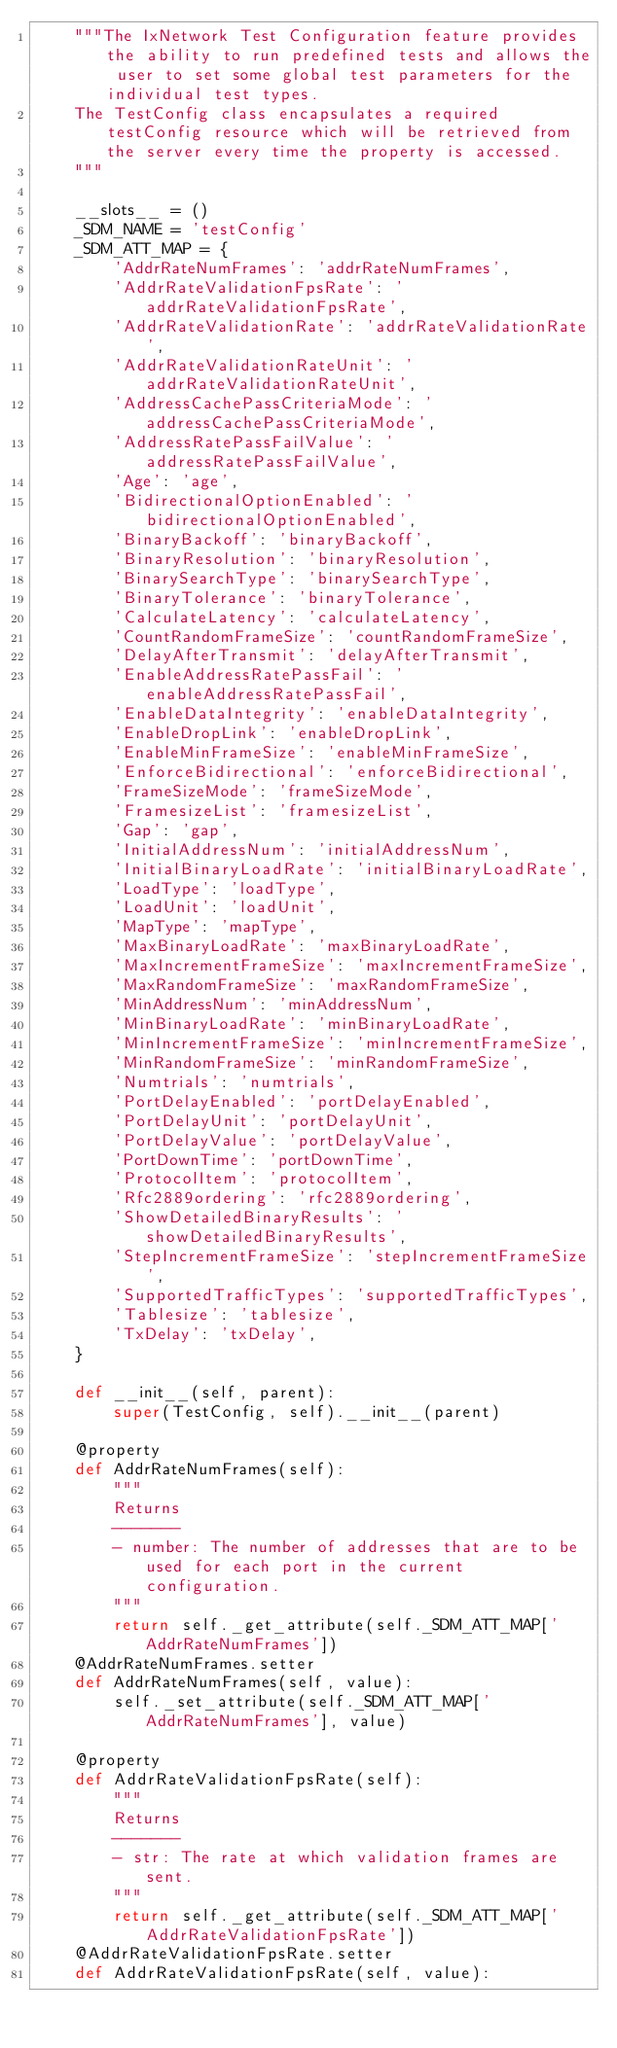Convert code to text. <code><loc_0><loc_0><loc_500><loc_500><_Python_>    """The IxNetwork Test Configuration feature provides the ability to run predefined tests and allows the user to set some global test parameters for the individual test types.
    The TestConfig class encapsulates a required testConfig resource which will be retrieved from the server every time the property is accessed.
    """

    __slots__ = ()
    _SDM_NAME = 'testConfig'
    _SDM_ATT_MAP = {
        'AddrRateNumFrames': 'addrRateNumFrames',
        'AddrRateValidationFpsRate': 'addrRateValidationFpsRate',
        'AddrRateValidationRate': 'addrRateValidationRate',
        'AddrRateValidationRateUnit': 'addrRateValidationRateUnit',
        'AddressCachePassCriteriaMode': 'addressCachePassCriteriaMode',
        'AddressRatePassFailValue': 'addressRatePassFailValue',
        'Age': 'age',
        'BidirectionalOptionEnabled': 'bidirectionalOptionEnabled',
        'BinaryBackoff': 'binaryBackoff',
        'BinaryResolution': 'binaryResolution',
        'BinarySearchType': 'binarySearchType',
        'BinaryTolerance': 'binaryTolerance',
        'CalculateLatency': 'calculateLatency',
        'CountRandomFrameSize': 'countRandomFrameSize',
        'DelayAfterTransmit': 'delayAfterTransmit',
        'EnableAddressRatePassFail': 'enableAddressRatePassFail',
        'EnableDataIntegrity': 'enableDataIntegrity',
        'EnableDropLink': 'enableDropLink',
        'EnableMinFrameSize': 'enableMinFrameSize',
        'EnforceBidirectional': 'enforceBidirectional',
        'FrameSizeMode': 'frameSizeMode',
        'FramesizeList': 'framesizeList',
        'Gap': 'gap',
        'InitialAddressNum': 'initialAddressNum',
        'InitialBinaryLoadRate': 'initialBinaryLoadRate',
        'LoadType': 'loadType',
        'LoadUnit': 'loadUnit',
        'MapType': 'mapType',
        'MaxBinaryLoadRate': 'maxBinaryLoadRate',
        'MaxIncrementFrameSize': 'maxIncrementFrameSize',
        'MaxRandomFrameSize': 'maxRandomFrameSize',
        'MinAddressNum': 'minAddressNum',
        'MinBinaryLoadRate': 'minBinaryLoadRate',
        'MinIncrementFrameSize': 'minIncrementFrameSize',
        'MinRandomFrameSize': 'minRandomFrameSize',
        'Numtrials': 'numtrials',
        'PortDelayEnabled': 'portDelayEnabled',
        'PortDelayUnit': 'portDelayUnit',
        'PortDelayValue': 'portDelayValue',
        'PortDownTime': 'portDownTime',
        'ProtocolItem': 'protocolItem',
        'Rfc2889ordering': 'rfc2889ordering',
        'ShowDetailedBinaryResults': 'showDetailedBinaryResults',
        'StepIncrementFrameSize': 'stepIncrementFrameSize',
        'SupportedTrafficTypes': 'supportedTrafficTypes',
        'Tablesize': 'tablesize',
        'TxDelay': 'txDelay',
    }

    def __init__(self, parent):
        super(TestConfig, self).__init__(parent)

    @property
    def AddrRateNumFrames(self):
        """
        Returns
        -------
        - number: The number of addresses that are to be used for each port in the current configuration.
        """
        return self._get_attribute(self._SDM_ATT_MAP['AddrRateNumFrames'])
    @AddrRateNumFrames.setter
    def AddrRateNumFrames(self, value):
        self._set_attribute(self._SDM_ATT_MAP['AddrRateNumFrames'], value)

    @property
    def AddrRateValidationFpsRate(self):
        """
        Returns
        -------
        - str: The rate at which validation frames are sent.
        """
        return self._get_attribute(self._SDM_ATT_MAP['AddrRateValidationFpsRate'])
    @AddrRateValidationFpsRate.setter
    def AddrRateValidationFpsRate(self, value):</code> 